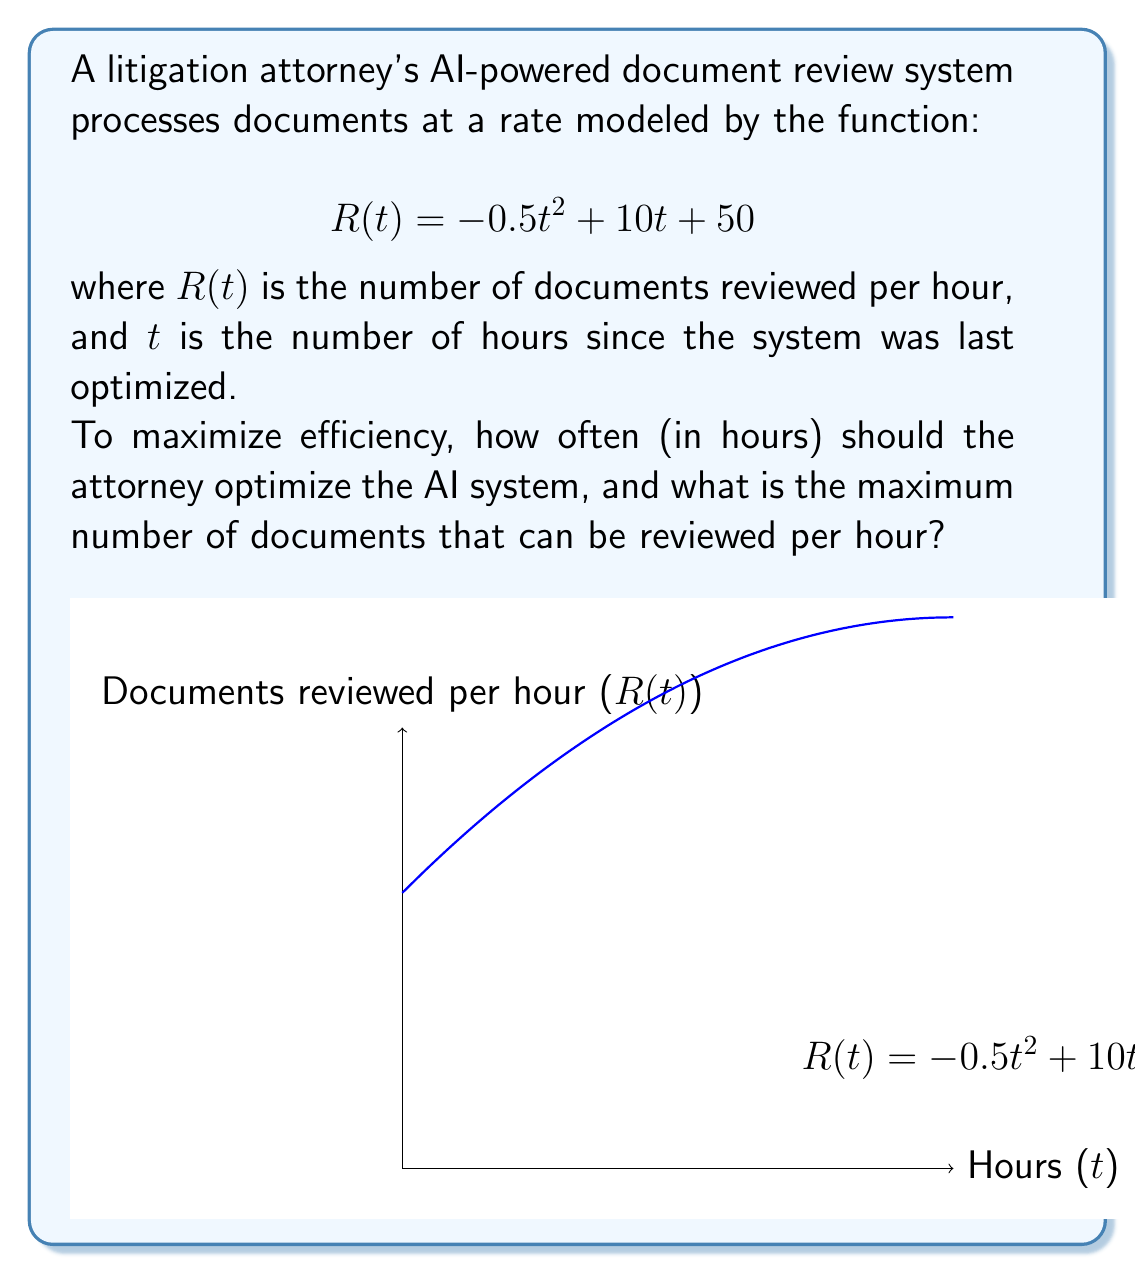Provide a solution to this math problem. To solve this optimization problem, we need to follow these steps:

1) First, we need to find the maximum of the function $R(t) = -0.5t^2 + 10t + 50$. This occurs at the vertex of the parabola.

2) To find the vertex, we can use the formula $t = -\frac{b}{2a}$ where $a$ and $b$ are the coefficients of $t^2$ and $t$ respectively in the quadratic function.

3) In this case, $a = -0.5$ and $b = 10$. So:

   $$t = -\frac{10}{2(-0.5)} = -\frac{10}{-1} = 10$$

4) This means the system should be optimized every 10 hours for maximum efficiency.

5) To find the maximum number of documents reviewed per hour, we substitute $t = 10$ into the original function:

   $$R(10) = -0.5(10)^2 + 10(10) + 50$$
   $$= -50 + 100 + 50$$
   $$= 100$$

Therefore, the maximum number of documents that can be reviewed per hour is 100.
Answer: Optimize every 10 hours; Maximum 100 documents/hour 